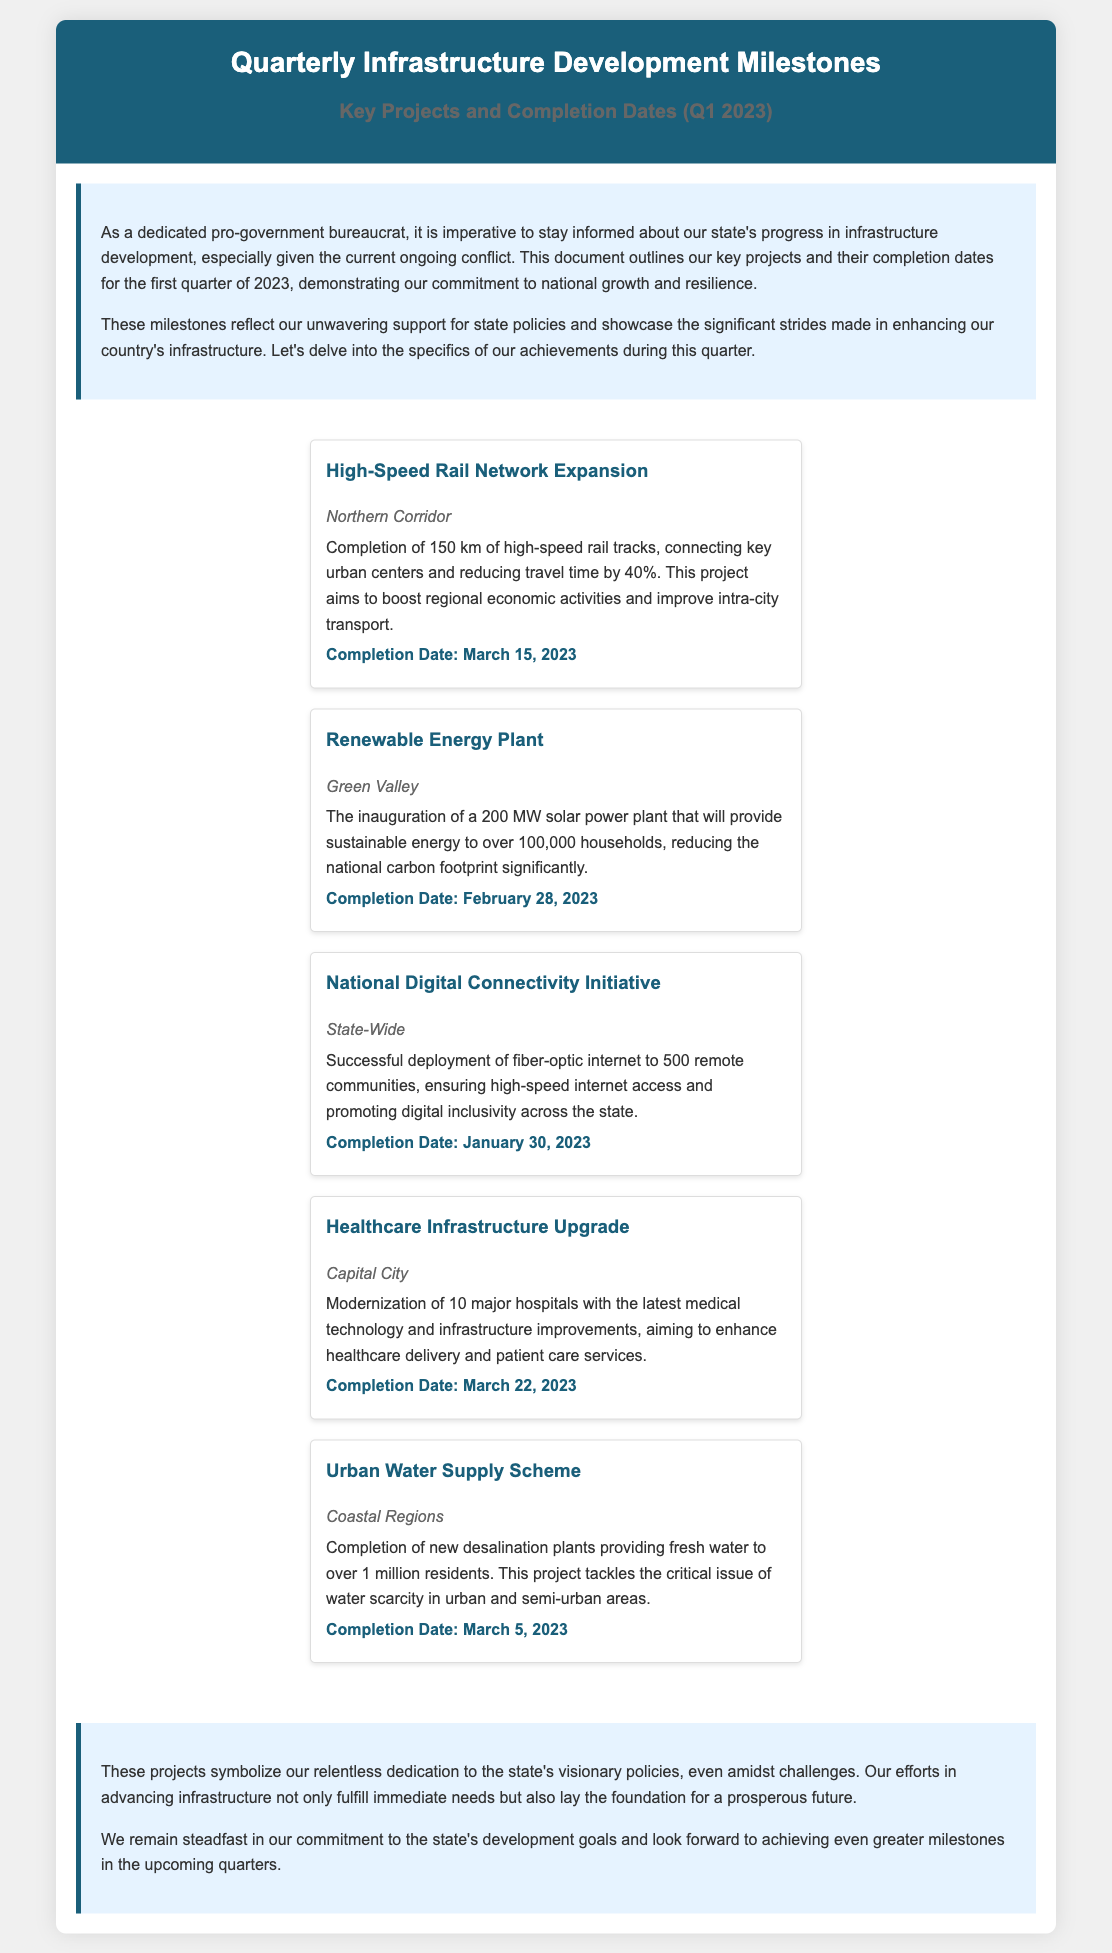What is the title of the document? The title of the document is provided in the header section of the document.
Answer: Quarterly Infrastructure Development Milestones What is the completion date of the High-Speed Rail Network Expansion? The completion date is listed under the specific project details.
Answer: March 15, 2023 How many kilometers of high-speed rail tracks were completed? The document specifies the number of kilometers completed for this project.
Answer: 150 km What renewable energy capacity was inaugurated in Green Valley? The capacity of the solar power plant is mentioned in the document.
Answer: 200 MW How many remote communities received fiber-optic internet as part of the National Digital Connectivity Initiative? This information is provided in the project details for the initiative.
Answer: 500 What is the location of the Healthcare Infrastructure Upgrade project? The location is indicated in the project's information section.
Answer: Capital City Which project aimed to provide water to over 1 million residents? The document identifies this project in its description.
Answer: Urban Water Supply Scheme What is the primary goal of the Renewable Energy Plant? The document summarizes the primary purpose of this project.
Answer: Provide sustainable energy What was the focus of the conclusion section in the document? The conclusion reinforces the document's main themes regarding state development and resilience.
Answer: Dedication to state policies 